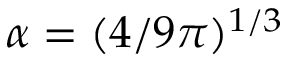<formula> <loc_0><loc_0><loc_500><loc_500>\alpha = ( 4 / 9 \pi ) ^ { 1 / 3 }</formula> 